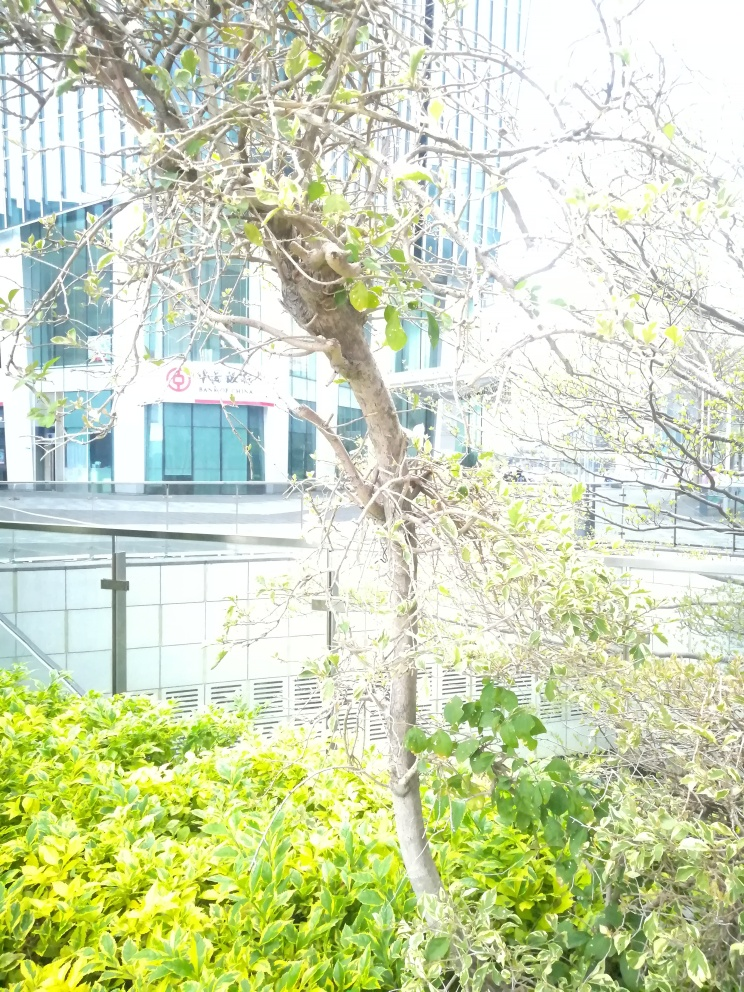What time of day does this photo seem to have been taken? The photo seems to have been taken during the daytime, as indicated by the strong presence of natural light and the lack of artificial light sources being visible. 